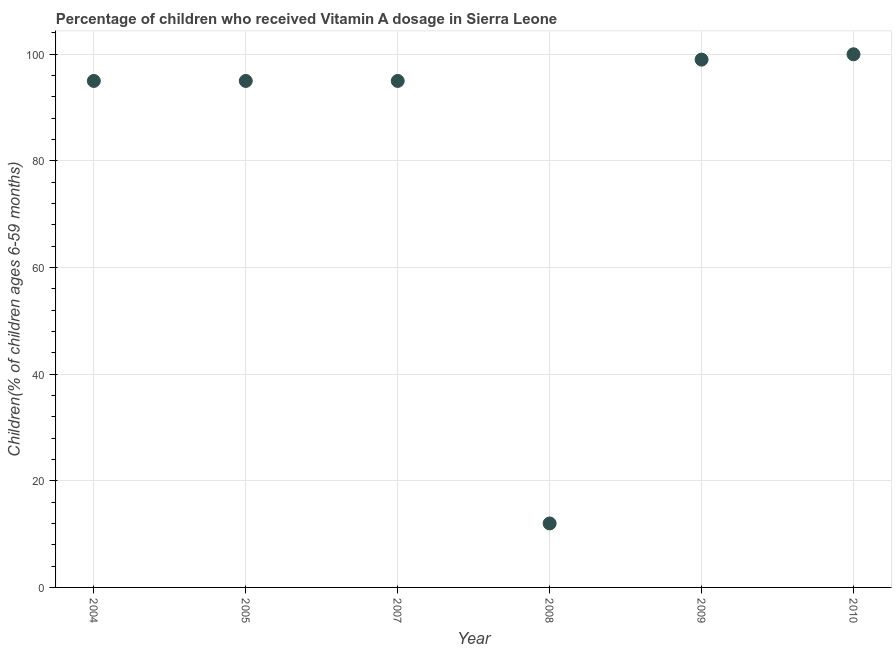What is the vitamin a supplementation coverage rate in 2010?
Ensure brevity in your answer.  100. Across all years, what is the maximum vitamin a supplementation coverage rate?
Make the answer very short. 100. Across all years, what is the minimum vitamin a supplementation coverage rate?
Your response must be concise. 12. What is the sum of the vitamin a supplementation coverage rate?
Offer a terse response. 496. What is the average vitamin a supplementation coverage rate per year?
Give a very brief answer. 82.67. In how many years, is the vitamin a supplementation coverage rate greater than 92 %?
Provide a succinct answer. 5. Is the difference between the vitamin a supplementation coverage rate in 2008 and 2009 greater than the difference between any two years?
Provide a short and direct response. No. What is the difference between the highest and the second highest vitamin a supplementation coverage rate?
Give a very brief answer. 1. What is the difference between the highest and the lowest vitamin a supplementation coverage rate?
Keep it short and to the point. 88. Does the vitamin a supplementation coverage rate monotonically increase over the years?
Ensure brevity in your answer.  No. Are the values on the major ticks of Y-axis written in scientific E-notation?
Offer a very short reply. No. Does the graph contain any zero values?
Provide a short and direct response. No. What is the title of the graph?
Your answer should be very brief. Percentage of children who received Vitamin A dosage in Sierra Leone. What is the label or title of the X-axis?
Your response must be concise. Year. What is the label or title of the Y-axis?
Provide a short and direct response. Children(% of children ages 6-59 months). What is the Children(% of children ages 6-59 months) in 2005?
Provide a short and direct response. 95. What is the Children(% of children ages 6-59 months) in 2007?
Give a very brief answer. 95. What is the Children(% of children ages 6-59 months) in 2009?
Offer a terse response. 99. What is the difference between the Children(% of children ages 6-59 months) in 2004 and 2008?
Give a very brief answer. 83. What is the difference between the Children(% of children ages 6-59 months) in 2004 and 2009?
Keep it short and to the point. -4. What is the difference between the Children(% of children ages 6-59 months) in 2005 and 2008?
Offer a very short reply. 83. What is the difference between the Children(% of children ages 6-59 months) in 2005 and 2009?
Offer a terse response. -4. What is the difference between the Children(% of children ages 6-59 months) in 2007 and 2010?
Offer a very short reply. -5. What is the difference between the Children(% of children ages 6-59 months) in 2008 and 2009?
Provide a short and direct response. -87. What is the difference between the Children(% of children ages 6-59 months) in 2008 and 2010?
Give a very brief answer. -88. What is the difference between the Children(% of children ages 6-59 months) in 2009 and 2010?
Provide a short and direct response. -1. What is the ratio of the Children(% of children ages 6-59 months) in 2004 to that in 2005?
Ensure brevity in your answer.  1. What is the ratio of the Children(% of children ages 6-59 months) in 2004 to that in 2007?
Keep it short and to the point. 1. What is the ratio of the Children(% of children ages 6-59 months) in 2004 to that in 2008?
Offer a very short reply. 7.92. What is the ratio of the Children(% of children ages 6-59 months) in 2004 to that in 2009?
Provide a succinct answer. 0.96. What is the ratio of the Children(% of children ages 6-59 months) in 2004 to that in 2010?
Offer a terse response. 0.95. What is the ratio of the Children(% of children ages 6-59 months) in 2005 to that in 2007?
Keep it short and to the point. 1. What is the ratio of the Children(% of children ages 6-59 months) in 2005 to that in 2008?
Your response must be concise. 7.92. What is the ratio of the Children(% of children ages 6-59 months) in 2007 to that in 2008?
Make the answer very short. 7.92. What is the ratio of the Children(% of children ages 6-59 months) in 2007 to that in 2009?
Your answer should be compact. 0.96. What is the ratio of the Children(% of children ages 6-59 months) in 2007 to that in 2010?
Provide a succinct answer. 0.95. What is the ratio of the Children(% of children ages 6-59 months) in 2008 to that in 2009?
Keep it short and to the point. 0.12. What is the ratio of the Children(% of children ages 6-59 months) in 2008 to that in 2010?
Keep it short and to the point. 0.12. What is the ratio of the Children(% of children ages 6-59 months) in 2009 to that in 2010?
Your answer should be very brief. 0.99. 